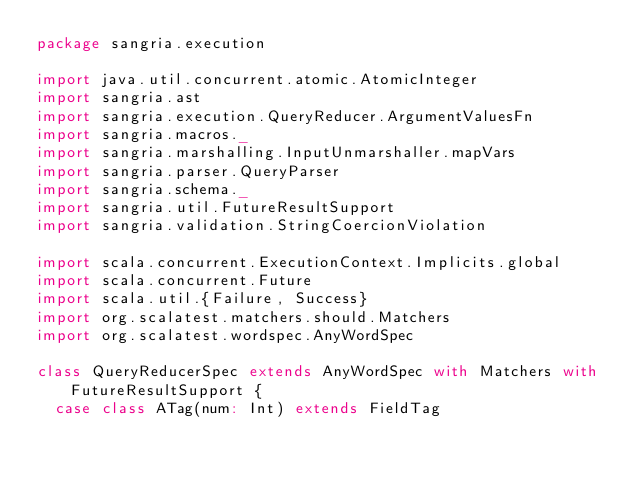Convert code to text. <code><loc_0><loc_0><loc_500><loc_500><_Scala_>package sangria.execution

import java.util.concurrent.atomic.AtomicInteger
import sangria.ast
import sangria.execution.QueryReducer.ArgumentValuesFn
import sangria.macros._
import sangria.marshalling.InputUnmarshaller.mapVars
import sangria.parser.QueryParser
import sangria.schema._
import sangria.util.FutureResultSupport
import sangria.validation.StringCoercionViolation

import scala.concurrent.ExecutionContext.Implicits.global
import scala.concurrent.Future
import scala.util.{Failure, Success}
import org.scalatest.matchers.should.Matchers
import org.scalatest.wordspec.AnyWordSpec

class QueryReducerSpec extends AnyWordSpec with Matchers with FutureResultSupport {
  case class ATag(num: Int) extends FieldTag</code> 